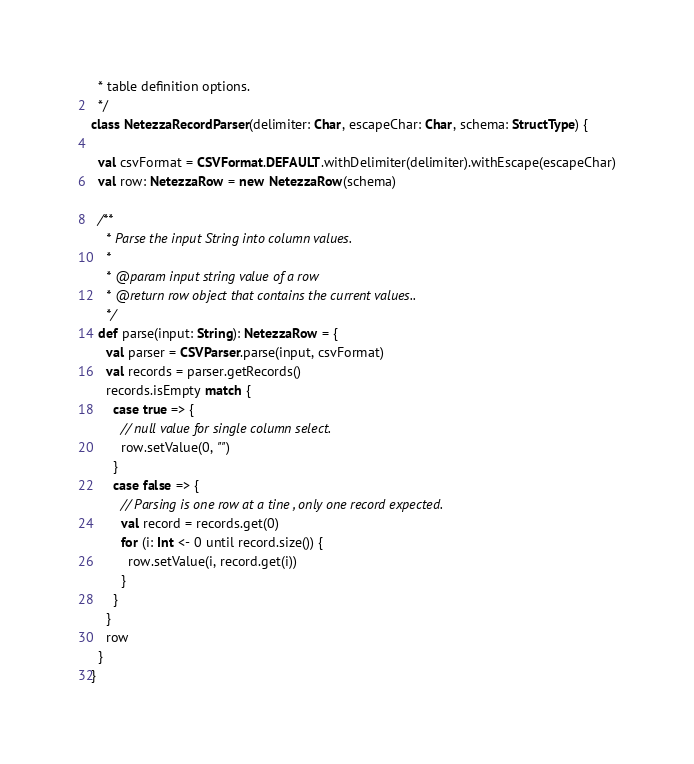Convert code to text. <code><loc_0><loc_0><loc_500><loc_500><_Scala_>  * table definition options.
  */
class NetezzaRecordParser(delimiter: Char, escapeChar: Char, schema: StructType) {

  val csvFormat = CSVFormat.DEFAULT.withDelimiter(delimiter).withEscape(escapeChar)
  val row: NetezzaRow = new NetezzaRow(schema)

  /**
    * Parse the input String into column values.
    *
    * @param input string value of a row
    * @return row object that contains the current values..
    */
  def parse(input: String): NetezzaRow = {
    val parser = CSVParser.parse(input, csvFormat)
    val records = parser.getRecords()
    records.isEmpty match {
      case true => {
        // null value for single column select.
        row.setValue(0, "")
      }
      case false => {
        // Parsing is one row at a tine , only one record expected.
        val record = records.get(0)
        for (i: Int <- 0 until record.size()) {
          row.setValue(i, record.get(i))
        }
      }
    }
    row
  }
}
</code> 